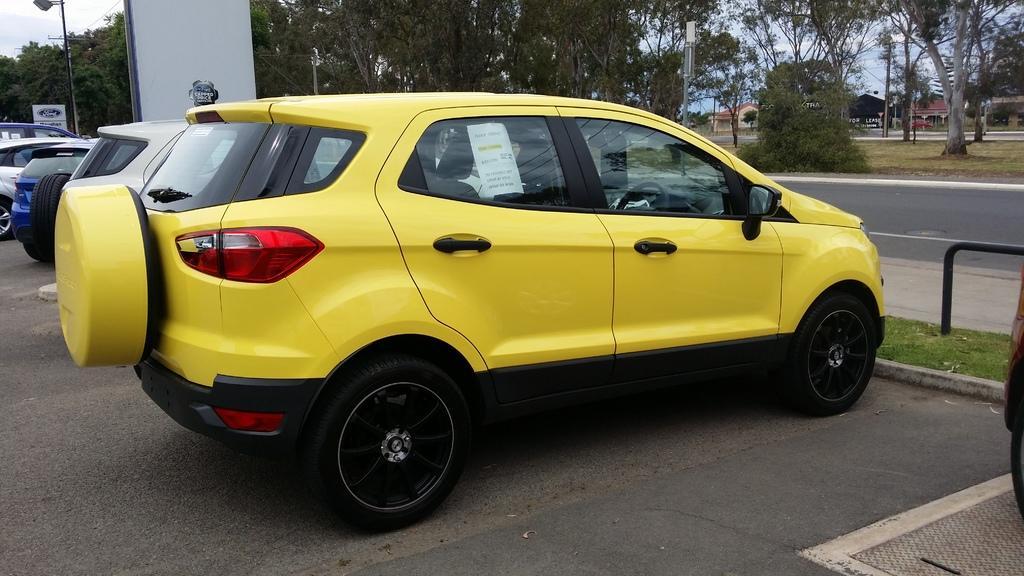Can you describe this image briefly? In this image, we can see some cars beside the road. There are some trees at the top of the image. There is a street pole in the top left of the image. 